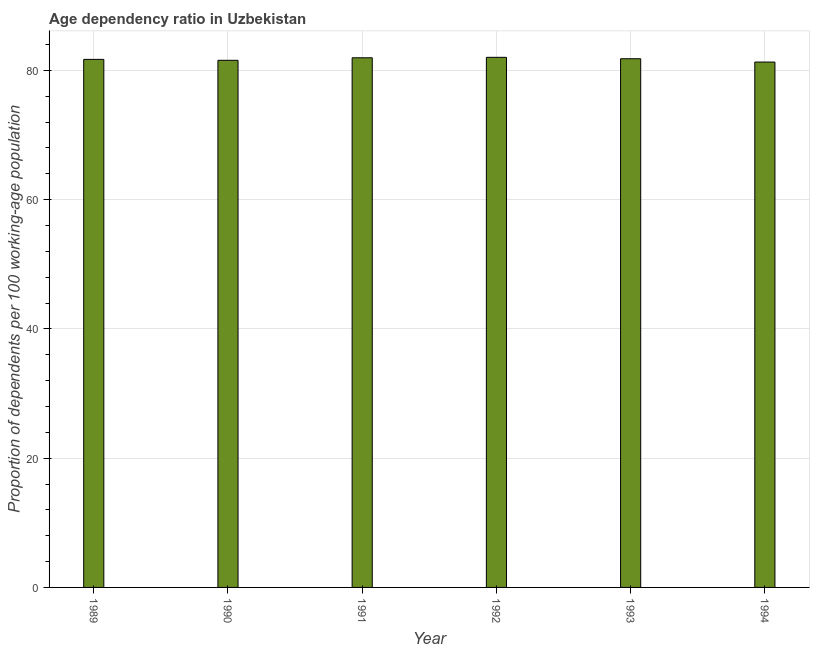What is the title of the graph?
Your response must be concise. Age dependency ratio in Uzbekistan. What is the label or title of the Y-axis?
Provide a short and direct response. Proportion of dependents per 100 working-age population. What is the age dependency ratio in 1993?
Your answer should be compact. 81.79. Across all years, what is the maximum age dependency ratio?
Provide a short and direct response. 82.01. Across all years, what is the minimum age dependency ratio?
Make the answer very short. 81.28. In which year was the age dependency ratio minimum?
Your response must be concise. 1994. What is the sum of the age dependency ratio?
Your answer should be very brief. 490.25. What is the difference between the age dependency ratio in 1992 and 1993?
Make the answer very short. 0.22. What is the average age dependency ratio per year?
Your response must be concise. 81.71. What is the median age dependency ratio?
Your response must be concise. 81.74. In how many years, is the age dependency ratio greater than 56 ?
Offer a very short reply. 6. Do a majority of the years between 1994 and 1989 (inclusive) have age dependency ratio greater than 80 ?
Your response must be concise. Yes. What is the difference between the highest and the second highest age dependency ratio?
Make the answer very short. 0.07. Is the sum of the age dependency ratio in 1989 and 1990 greater than the maximum age dependency ratio across all years?
Give a very brief answer. Yes. What is the difference between the highest and the lowest age dependency ratio?
Provide a succinct answer. 0.73. In how many years, is the age dependency ratio greater than the average age dependency ratio taken over all years?
Make the answer very short. 3. How many years are there in the graph?
Offer a very short reply. 6. What is the Proportion of dependents per 100 working-age population of 1989?
Provide a short and direct response. 81.69. What is the Proportion of dependents per 100 working-age population of 1990?
Keep it short and to the point. 81.55. What is the Proportion of dependents per 100 working-age population of 1991?
Your response must be concise. 81.94. What is the Proportion of dependents per 100 working-age population in 1992?
Give a very brief answer. 82.01. What is the Proportion of dependents per 100 working-age population in 1993?
Provide a short and direct response. 81.79. What is the Proportion of dependents per 100 working-age population in 1994?
Your answer should be very brief. 81.28. What is the difference between the Proportion of dependents per 100 working-age population in 1989 and 1990?
Ensure brevity in your answer.  0.14. What is the difference between the Proportion of dependents per 100 working-age population in 1989 and 1991?
Your response must be concise. -0.25. What is the difference between the Proportion of dependents per 100 working-age population in 1989 and 1992?
Your answer should be very brief. -0.32. What is the difference between the Proportion of dependents per 100 working-age population in 1989 and 1993?
Provide a succinct answer. -0.1. What is the difference between the Proportion of dependents per 100 working-age population in 1989 and 1994?
Provide a short and direct response. 0.41. What is the difference between the Proportion of dependents per 100 working-age population in 1990 and 1991?
Make the answer very short. -0.39. What is the difference between the Proportion of dependents per 100 working-age population in 1990 and 1992?
Ensure brevity in your answer.  -0.46. What is the difference between the Proportion of dependents per 100 working-age population in 1990 and 1993?
Make the answer very short. -0.24. What is the difference between the Proportion of dependents per 100 working-age population in 1990 and 1994?
Your answer should be compact. 0.27. What is the difference between the Proportion of dependents per 100 working-age population in 1991 and 1992?
Keep it short and to the point. -0.07. What is the difference between the Proportion of dependents per 100 working-age population in 1991 and 1993?
Provide a short and direct response. 0.15. What is the difference between the Proportion of dependents per 100 working-age population in 1991 and 1994?
Ensure brevity in your answer.  0.66. What is the difference between the Proportion of dependents per 100 working-age population in 1992 and 1993?
Provide a succinct answer. 0.22. What is the difference between the Proportion of dependents per 100 working-age population in 1992 and 1994?
Make the answer very short. 0.73. What is the difference between the Proportion of dependents per 100 working-age population in 1993 and 1994?
Make the answer very short. 0.51. What is the ratio of the Proportion of dependents per 100 working-age population in 1989 to that in 1991?
Keep it short and to the point. 1. What is the ratio of the Proportion of dependents per 100 working-age population in 1989 to that in 1992?
Provide a succinct answer. 1. What is the ratio of the Proportion of dependents per 100 working-age population in 1989 to that in 1993?
Give a very brief answer. 1. What is the ratio of the Proportion of dependents per 100 working-age population in 1989 to that in 1994?
Give a very brief answer. 1. What is the ratio of the Proportion of dependents per 100 working-age population in 1990 to that in 1991?
Provide a succinct answer. 0.99. What is the ratio of the Proportion of dependents per 100 working-age population in 1990 to that in 1994?
Offer a very short reply. 1. What is the ratio of the Proportion of dependents per 100 working-age population in 1991 to that in 1992?
Offer a terse response. 1. What is the ratio of the Proportion of dependents per 100 working-age population in 1991 to that in 1993?
Give a very brief answer. 1. What is the ratio of the Proportion of dependents per 100 working-age population in 1992 to that in 1994?
Provide a succinct answer. 1.01. 